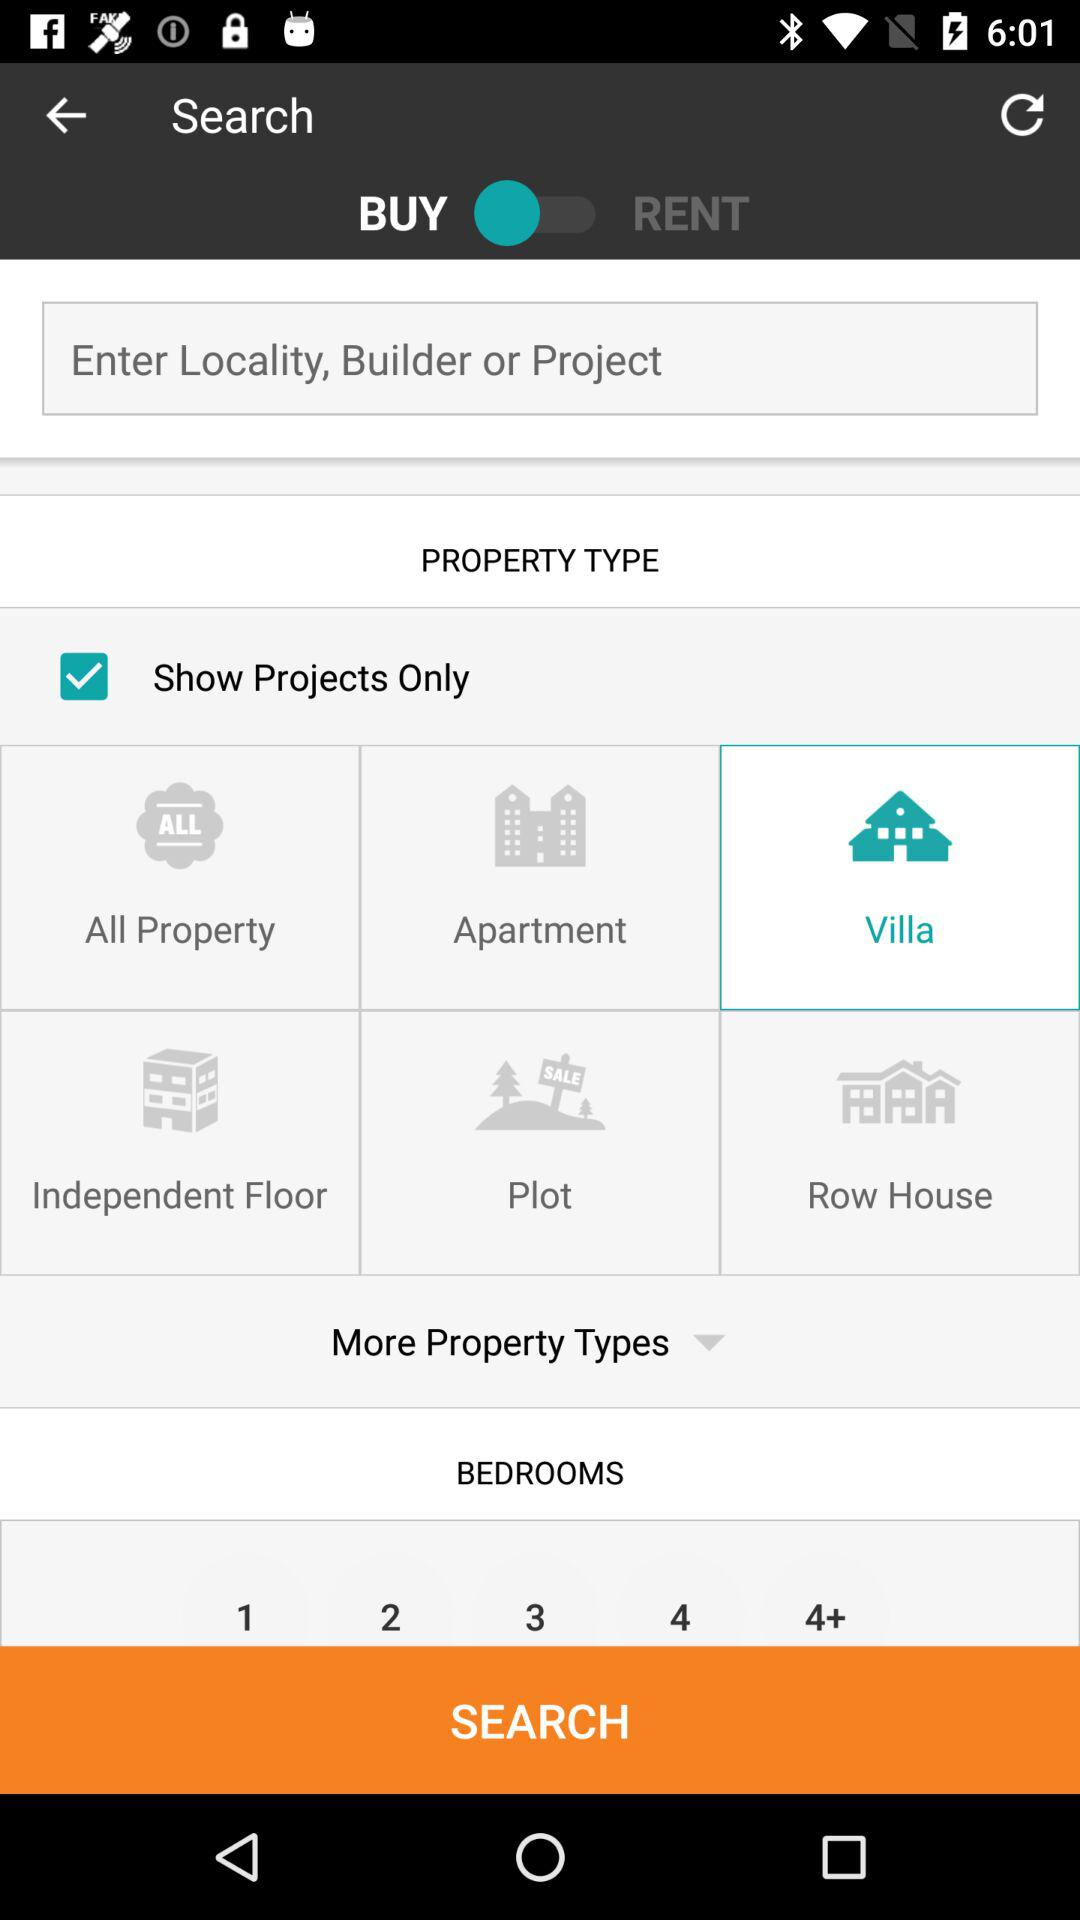What's the setting for buy and rent option?
When the provided information is insufficient, respond with <no answer>. <no answer> 